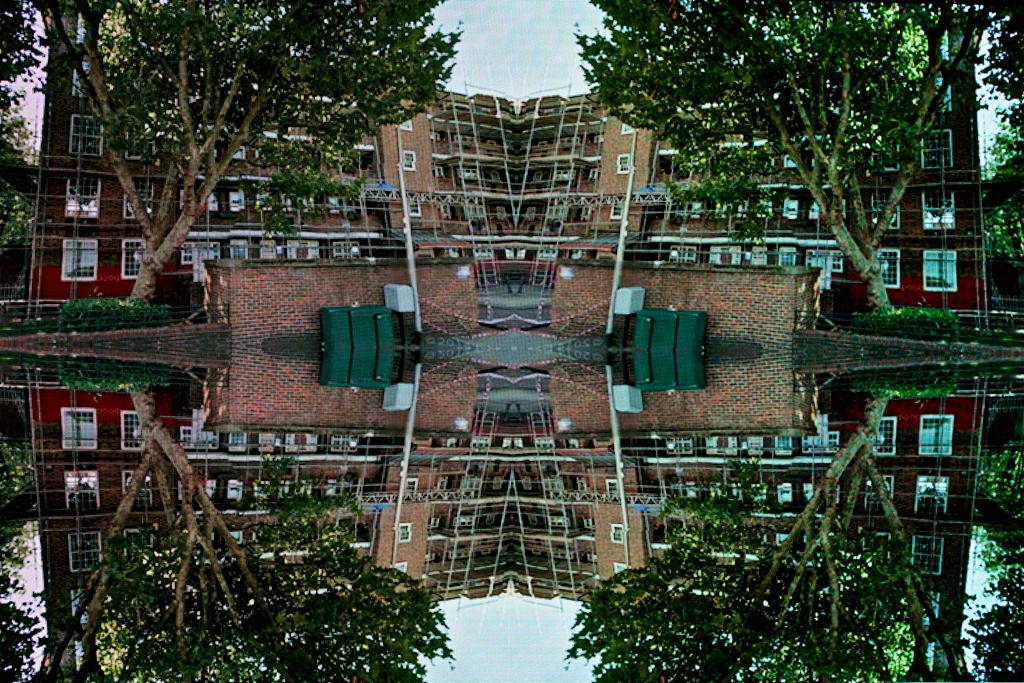What type of vegetation can be seen in the image? There are trees in the image. What type of structures are present in the image? There are buildings in the image. What can be observed about the water in the image? The water in the image reflects the trees and the buildings. Can you see a rat biting a snail in the image? No, there is no rat or snail present in the image. 